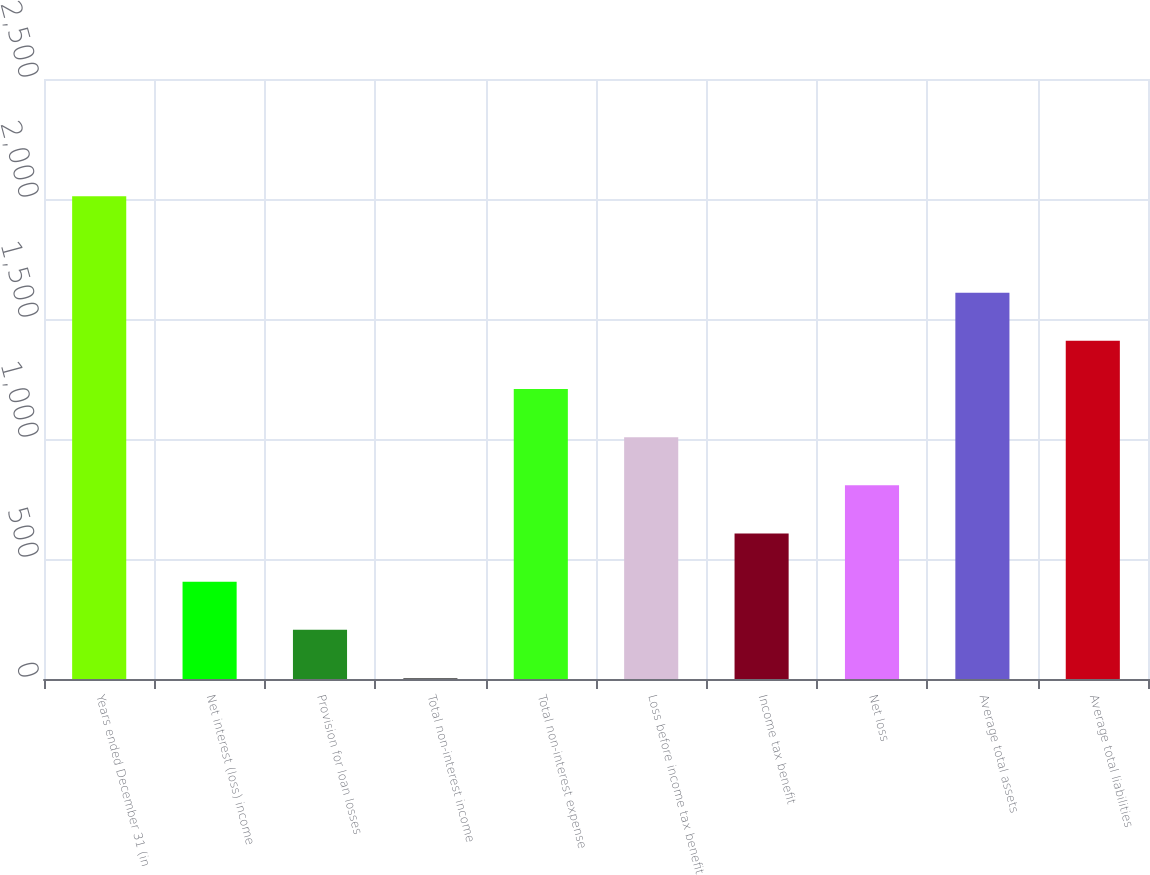Convert chart to OTSL. <chart><loc_0><loc_0><loc_500><loc_500><bar_chart><fcel>Years ended December 31 (in<fcel>Net interest (loss) income<fcel>Provision for loan losses<fcel>Total non-interest income<fcel>Total non-interest expense<fcel>Loss before income tax benefit<fcel>Income tax benefit<fcel>Net loss<fcel>Average total assets<fcel>Average total liabilities<nl><fcel>2011<fcel>405.4<fcel>204.7<fcel>4<fcel>1208.2<fcel>1007.5<fcel>606.1<fcel>806.8<fcel>1609.6<fcel>1408.9<nl></chart> 